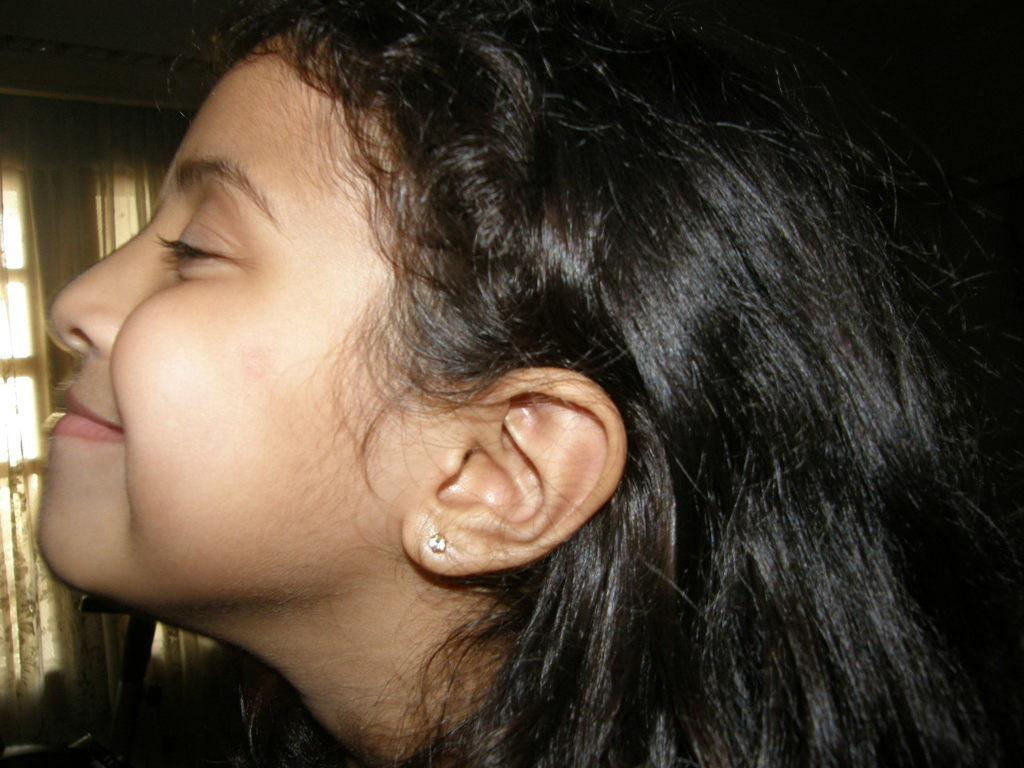Who is the main subject in the image? There is a girl in the image. What is the girl wearing in her ears? The girl is wearing ear studs. What is the girl's facial expression in the image? The girl is smiling. What can be seen in the background of the image? There is a window in the image. What type of window treatment is visible in the image? There are window curtains visible in the image. Can you see any deer in the image? There are no deer present in the image. What type of cracker is the girl holding in the image? There is no cracker visible in the image. 